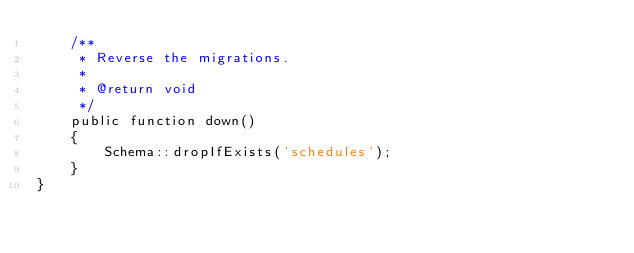<code> <loc_0><loc_0><loc_500><loc_500><_PHP_>    /**
     * Reverse the migrations.
     *
     * @return void
     */
    public function down()
    {
        Schema::dropIfExists('schedules');
    }
}
</code> 